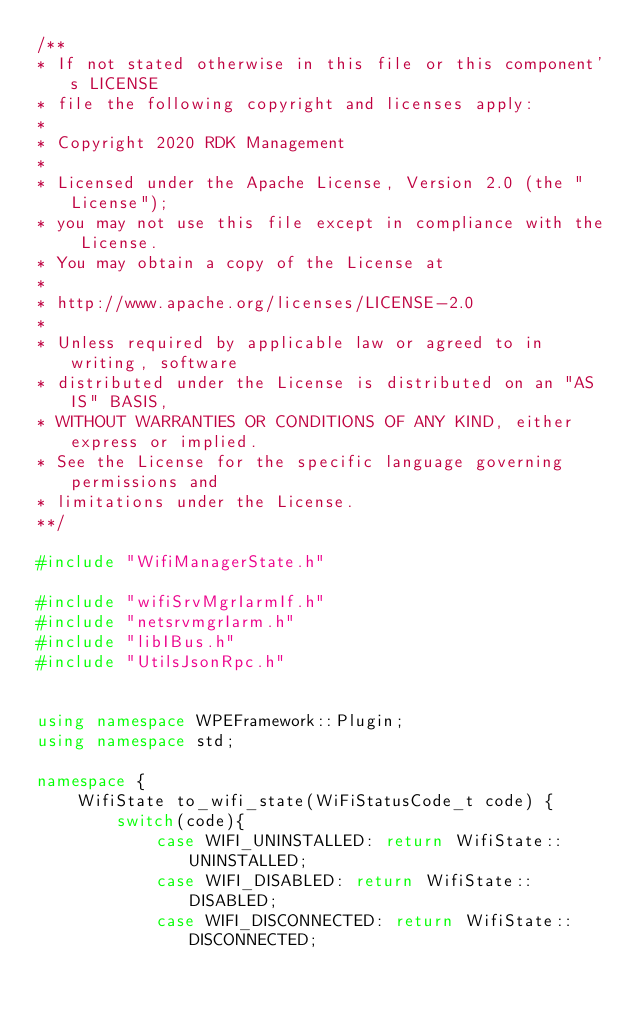Convert code to text. <code><loc_0><loc_0><loc_500><loc_500><_C++_>/**
* If not stated otherwise in this file or this component's LICENSE
* file the following copyright and licenses apply:
*
* Copyright 2020 RDK Management
*
* Licensed under the Apache License, Version 2.0 (the "License");
* you may not use this file except in compliance with the License.
* You may obtain a copy of the License at
*
* http://www.apache.org/licenses/LICENSE-2.0
*
* Unless required by applicable law or agreed to in writing, software
* distributed under the License is distributed on an "AS IS" BASIS,
* WITHOUT WARRANTIES OR CONDITIONS OF ANY KIND, either express or implied.
* See the License for the specific language governing permissions and
* limitations under the License.
**/

#include "WifiManagerState.h"

#include "wifiSrvMgrIarmIf.h"
#include "netsrvmgrIarm.h"
#include "libIBus.h"
#include "UtilsJsonRpc.h"


using namespace WPEFramework::Plugin;
using namespace std;

namespace {
    WifiState to_wifi_state(WiFiStatusCode_t code) {
        switch(code){
            case WIFI_UNINSTALLED: return WifiState::UNINSTALLED;
            case WIFI_DISABLED: return WifiState::DISABLED;
            case WIFI_DISCONNECTED: return WifiState::DISCONNECTED;</code> 